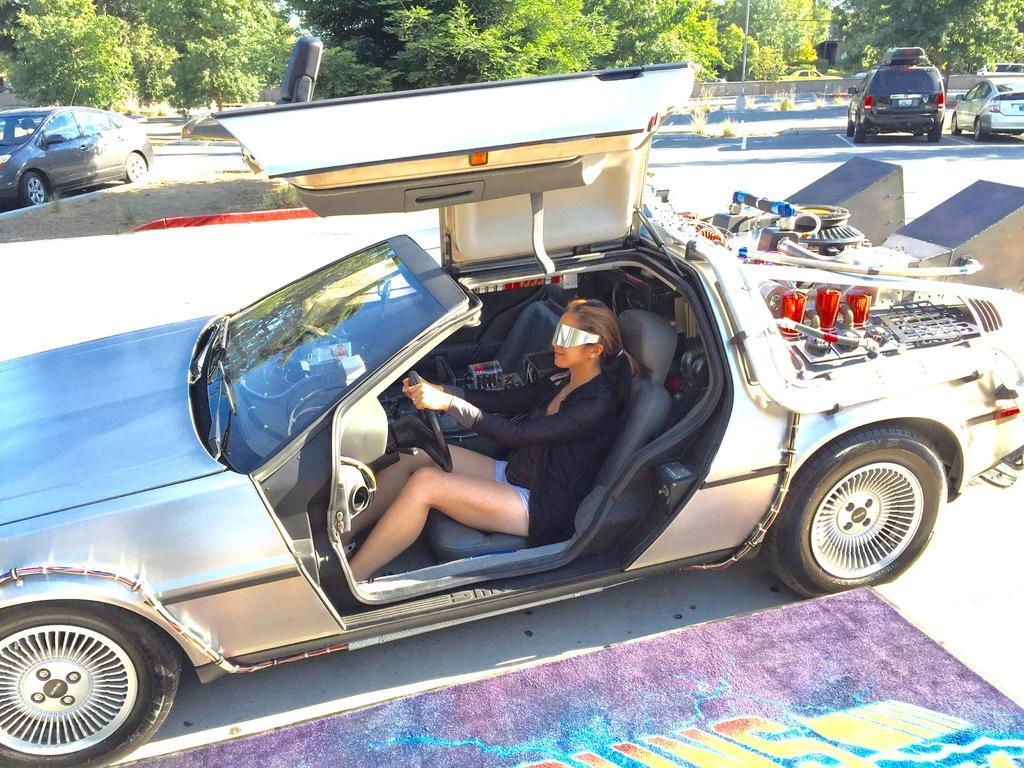In one or two sentences, can you explain what this image depicts? In this picture we can see vehicles on the road, trees and a woman sitting in a vehicle and holding a steering with her hands. 